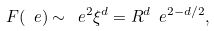Convert formula to latex. <formula><loc_0><loc_0><loc_500><loc_500>F ( \ e ) \sim \ e ^ { 2 } \xi ^ { d } = R ^ { d } \ e ^ { 2 - d / 2 } ,</formula> 